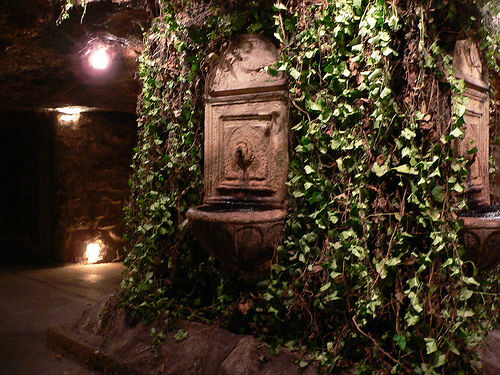<image>
Can you confirm if the leaf is on the wall? No. The leaf is not positioned on the wall. They may be near each other, but the leaf is not supported by or resting on top of the wall. 